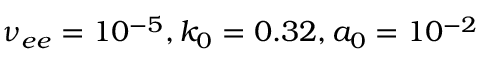<formula> <loc_0><loc_0><loc_500><loc_500>\nu _ { e e } = 1 0 ^ { - 5 } , k _ { 0 } = 0 . 3 2 , a _ { 0 } = 1 0 ^ { - 2 }</formula> 